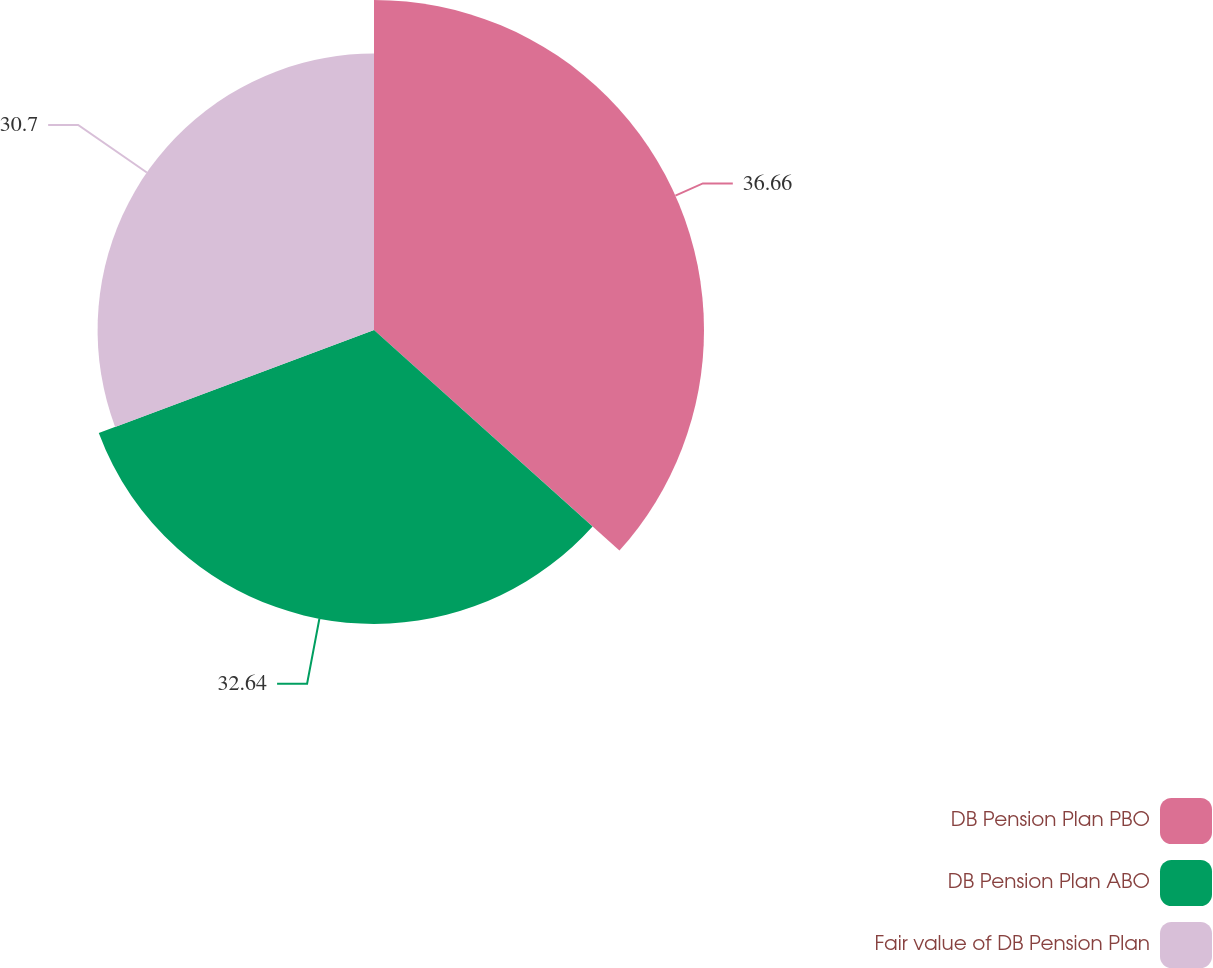Convert chart to OTSL. <chart><loc_0><loc_0><loc_500><loc_500><pie_chart><fcel>DB Pension Plan PBO<fcel>DB Pension Plan ABO<fcel>Fair value of DB Pension Plan<nl><fcel>36.65%<fcel>32.64%<fcel>30.7%<nl></chart> 